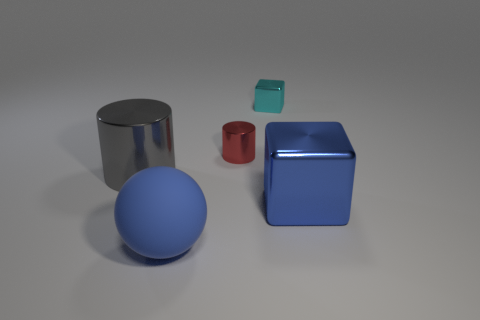Add 1 large gray metal cylinders. How many objects exist? 6 Add 1 tiny red cylinders. How many tiny red cylinders are left? 2 Add 4 red things. How many red things exist? 5 Subtract 0 brown blocks. How many objects are left? 5 Subtract all balls. How many objects are left? 4 Subtract all big metal cylinders. Subtract all big purple shiny things. How many objects are left? 4 